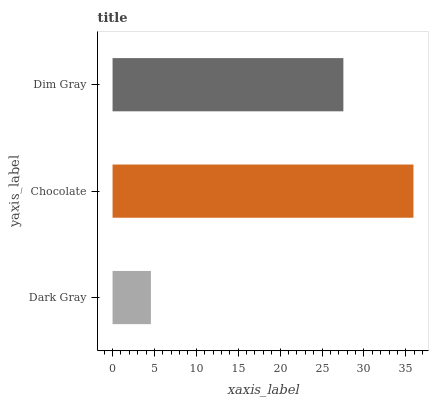Is Dark Gray the minimum?
Answer yes or no. Yes. Is Chocolate the maximum?
Answer yes or no. Yes. Is Dim Gray the minimum?
Answer yes or no. No. Is Dim Gray the maximum?
Answer yes or no. No. Is Chocolate greater than Dim Gray?
Answer yes or no. Yes. Is Dim Gray less than Chocolate?
Answer yes or no. Yes. Is Dim Gray greater than Chocolate?
Answer yes or no. No. Is Chocolate less than Dim Gray?
Answer yes or no. No. Is Dim Gray the high median?
Answer yes or no. Yes. Is Dim Gray the low median?
Answer yes or no. Yes. Is Dark Gray the high median?
Answer yes or no. No. Is Dark Gray the low median?
Answer yes or no. No. 